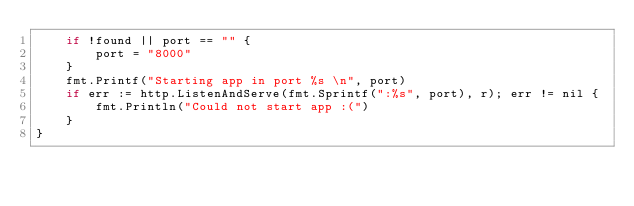<code> <loc_0><loc_0><loc_500><loc_500><_Go_>	if !found || port == "" {
		port = "8000"
	}
	fmt.Printf("Starting app in port %s \n", port)
	if err := http.ListenAndServe(fmt.Sprintf(":%s", port), r); err != nil {
		fmt.Println("Could not start app :(")
	}
}
</code> 